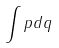Convert formula to latex. <formula><loc_0><loc_0><loc_500><loc_500>\int p d q</formula> 